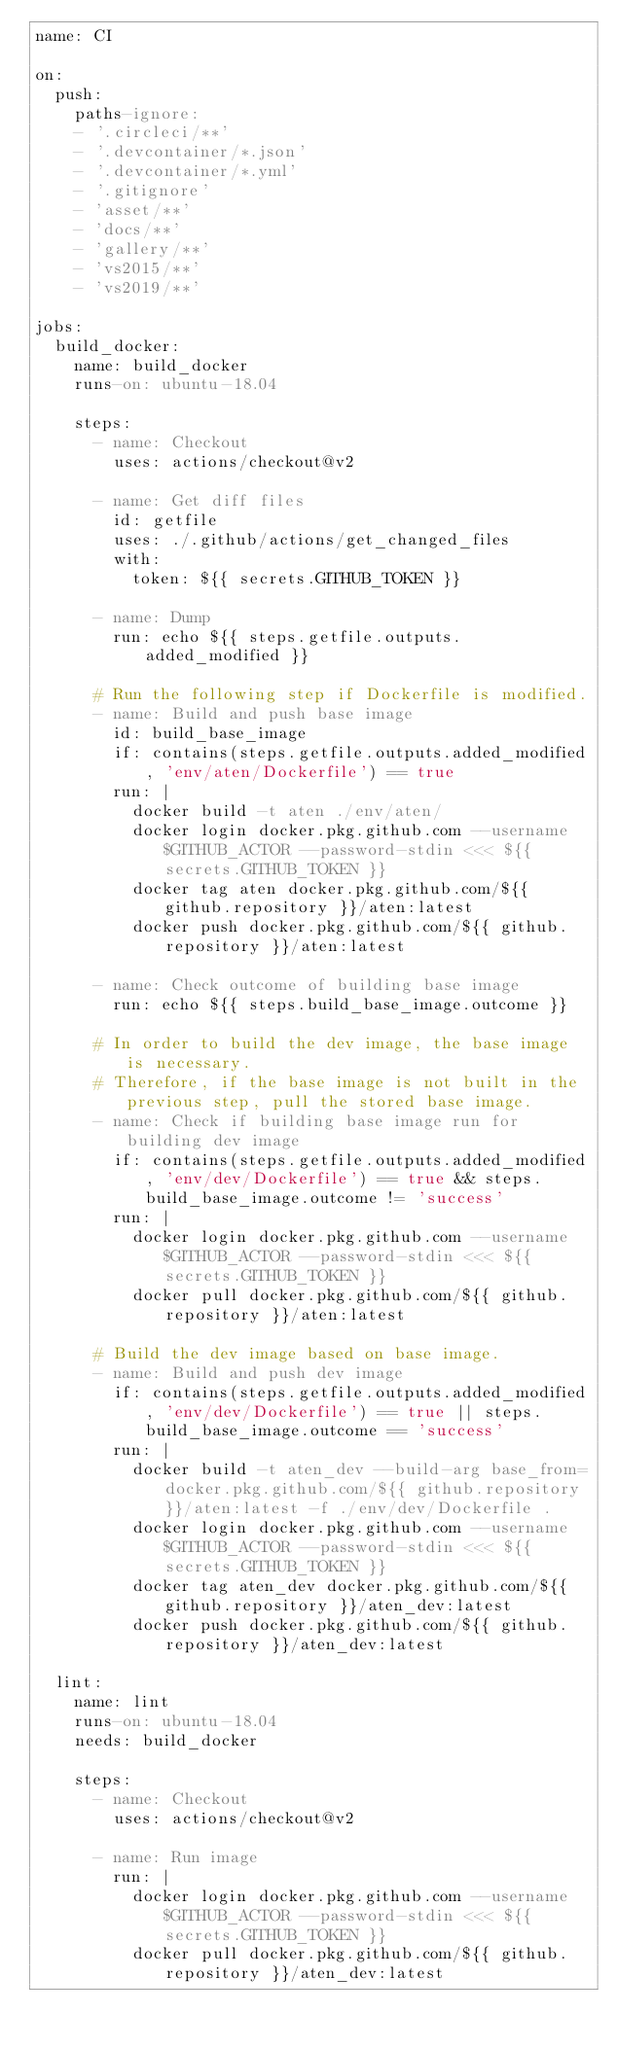Convert code to text. <code><loc_0><loc_0><loc_500><loc_500><_YAML_>name: CI

on:
  push:
    paths-ignore:
    - '.circleci/**'
    - '.devcontainer/*.json'
    - '.devcontainer/*.yml'
    - '.gitignore'
    - 'asset/**'
    - 'docs/**'
    - 'gallery/**'
    - 'vs2015/**'
    - 'vs2019/**'

jobs:
  build_docker:
    name: build_docker
    runs-on: ubuntu-18.04

    steps:
      - name: Checkout
        uses: actions/checkout@v2

      - name: Get diff files
        id: getfile
        uses: ./.github/actions/get_changed_files
        with:
          token: ${{ secrets.GITHUB_TOKEN }}

      - name: Dump
        run: echo ${{ steps.getfile.outputs.added_modified }}

      # Run the following step if Dockerfile is modified.
      - name: Build and push base image
        id: build_base_image
        if: contains(steps.getfile.outputs.added_modified, 'env/aten/Dockerfile') == true
        run: |
          docker build -t aten ./env/aten/
          docker login docker.pkg.github.com --username $GITHUB_ACTOR --password-stdin <<< ${{ secrets.GITHUB_TOKEN }}
          docker tag aten docker.pkg.github.com/${{ github.repository }}/aten:latest
          docker push docker.pkg.github.com/${{ github.repository }}/aten:latest

      - name: Check outcome of building base image
        run: echo ${{ steps.build_base_image.outcome }}

      # In order to build the dev image, the base image is necessary.
      # Therefore, if the base image is not built in the previous step, pull the stored base image.
      - name: Check if building base image run for building dev image
        if: contains(steps.getfile.outputs.added_modified, 'env/dev/Dockerfile') == true && steps.build_base_image.outcome != 'success'
        run: |
          docker login docker.pkg.github.com --username $GITHUB_ACTOR --password-stdin <<< ${{ secrets.GITHUB_TOKEN }}
          docker pull docker.pkg.github.com/${{ github.repository }}/aten:latest

      # Build the dev image based on base image.
      - name: Build and push dev image
        if: contains(steps.getfile.outputs.added_modified, 'env/dev/Dockerfile') == true || steps.build_base_image.outcome == 'success'
        run: |
          docker build -t aten_dev --build-arg base_from=docker.pkg.github.com/${{ github.repository }}/aten:latest -f ./env/dev/Dockerfile .
          docker login docker.pkg.github.com --username $GITHUB_ACTOR --password-stdin <<< ${{ secrets.GITHUB_TOKEN }}
          docker tag aten_dev docker.pkg.github.com/${{ github.repository }}/aten_dev:latest
          docker push docker.pkg.github.com/${{ github.repository }}/aten_dev:latest

  lint:
    name: lint
    runs-on: ubuntu-18.04
    needs: build_docker

    steps:
      - name: Checkout
        uses: actions/checkout@v2

      - name: Run image
        run: |
          docker login docker.pkg.github.com --username $GITHUB_ACTOR --password-stdin <<< ${{ secrets.GITHUB_TOKEN }}
          docker pull docker.pkg.github.com/${{ github.repository }}/aten_dev:latest</code> 